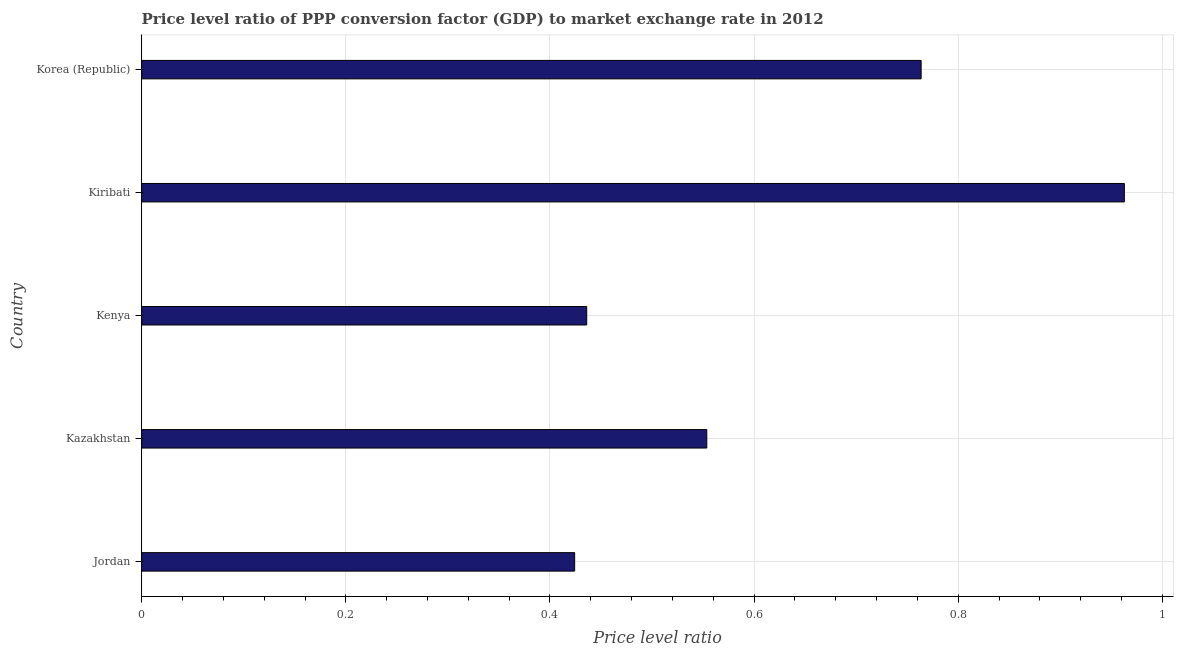Does the graph contain any zero values?
Your answer should be compact. No. What is the title of the graph?
Your answer should be compact. Price level ratio of PPP conversion factor (GDP) to market exchange rate in 2012. What is the label or title of the X-axis?
Your response must be concise. Price level ratio. What is the price level ratio in Kenya?
Ensure brevity in your answer.  0.44. Across all countries, what is the maximum price level ratio?
Ensure brevity in your answer.  0.96. Across all countries, what is the minimum price level ratio?
Offer a terse response. 0.42. In which country was the price level ratio maximum?
Provide a succinct answer. Kiribati. In which country was the price level ratio minimum?
Your response must be concise. Jordan. What is the sum of the price level ratio?
Offer a very short reply. 3.14. What is the difference between the price level ratio in Jordan and Kiribati?
Provide a succinct answer. -0.54. What is the average price level ratio per country?
Ensure brevity in your answer.  0.63. What is the median price level ratio?
Provide a succinct answer. 0.55. What is the ratio of the price level ratio in Kiribati to that in Korea (Republic)?
Offer a very short reply. 1.26. Is the price level ratio in Jordan less than that in Kenya?
Make the answer very short. Yes. Is the difference between the price level ratio in Jordan and Korea (Republic) greater than the difference between any two countries?
Make the answer very short. No. What is the difference between the highest and the second highest price level ratio?
Your answer should be very brief. 0.2. What is the difference between the highest and the lowest price level ratio?
Offer a terse response. 0.54. In how many countries, is the price level ratio greater than the average price level ratio taken over all countries?
Provide a succinct answer. 2. How many bars are there?
Make the answer very short. 5. How many countries are there in the graph?
Ensure brevity in your answer.  5. What is the difference between two consecutive major ticks on the X-axis?
Ensure brevity in your answer.  0.2. What is the Price level ratio of Jordan?
Your answer should be very brief. 0.42. What is the Price level ratio of Kazakhstan?
Keep it short and to the point. 0.55. What is the Price level ratio of Kenya?
Make the answer very short. 0.44. What is the Price level ratio of Kiribati?
Your response must be concise. 0.96. What is the Price level ratio of Korea (Republic)?
Offer a very short reply. 0.76. What is the difference between the Price level ratio in Jordan and Kazakhstan?
Provide a short and direct response. -0.13. What is the difference between the Price level ratio in Jordan and Kenya?
Keep it short and to the point. -0.01. What is the difference between the Price level ratio in Jordan and Kiribati?
Offer a terse response. -0.54. What is the difference between the Price level ratio in Jordan and Korea (Republic)?
Give a very brief answer. -0.34. What is the difference between the Price level ratio in Kazakhstan and Kenya?
Keep it short and to the point. 0.12. What is the difference between the Price level ratio in Kazakhstan and Kiribati?
Your answer should be very brief. -0.41. What is the difference between the Price level ratio in Kazakhstan and Korea (Republic)?
Your answer should be very brief. -0.21. What is the difference between the Price level ratio in Kenya and Kiribati?
Make the answer very short. -0.53. What is the difference between the Price level ratio in Kenya and Korea (Republic)?
Offer a very short reply. -0.33. What is the difference between the Price level ratio in Kiribati and Korea (Republic)?
Keep it short and to the point. 0.2. What is the ratio of the Price level ratio in Jordan to that in Kazakhstan?
Your response must be concise. 0.77. What is the ratio of the Price level ratio in Jordan to that in Kenya?
Provide a short and direct response. 0.97. What is the ratio of the Price level ratio in Jordan to that in Kiribati?
Provide a short and direct response. 0.44. What is the ratio of the Price level ratio in Jordan to that in Korea (Republic)?
Offer a terse response. 0.56. What is the ratio of the Price level ratio in Kazakhstan to that in Kenya?
Provide a succinct answer. 1.27. What is the ratio of the Price level ratio in Kazakhstan to that in Kiribati?
Provide a succinct answer. 0.57. What is the ratio of the Price level ratio in Kazakhstan to that in Korea (Republic)?
Your answer should be very brief. 0.72. What is the ratio of the Price level ratio in Kenya to that in Kiribati?
Your answer should be very brief. 0.45. What is the ratio of the Price level ratio in Kenya to that in Korea (Republic)?
Your response must be concise. 0.57. What is the ratio of the Price level ratio in Kiribati to that in Korea (Republic)?
Keep it short and to the point. 1.26. 